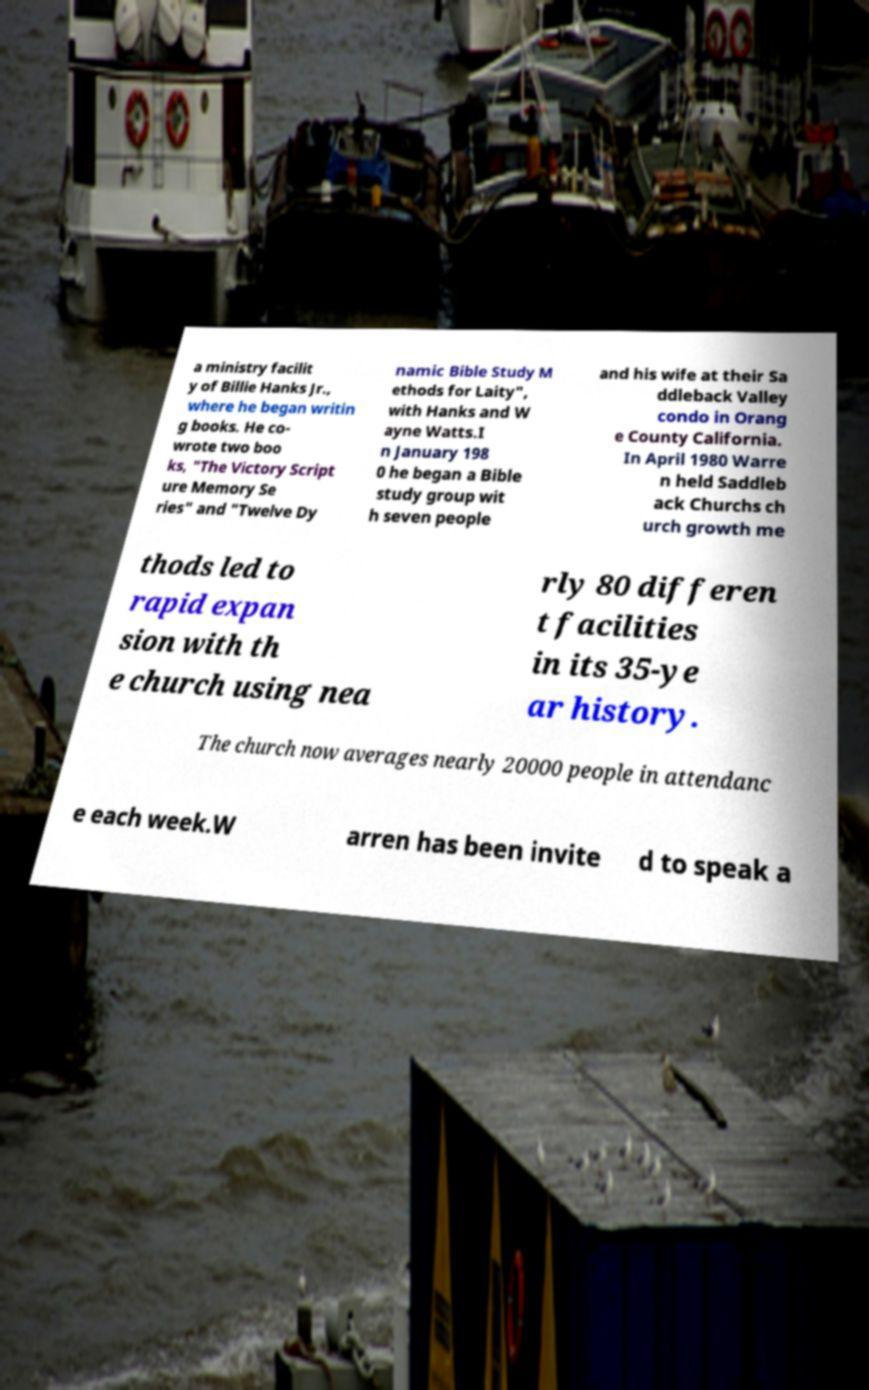For documentation purposes, I need the text within this image transcribed. Could you provide that? a ministry facilit y of Billie Hanks Jr., where he began writin g books. He co- wrote two boo ks, "The Victory Script ure Memory Se ries" and "Twelve Dy namic Bible Study M ethods for Laity", with Hanks and W ayne Watts.I n January 198 0 he began a Bible study group wit h seven people and his wife at their Sa ddleback Valley condo in Orang e County California. In April 1980 Warre n held Saddleb ack Churchs ch urch growth me thods led to rapid expan sion with th e church using nea rly 80 differen t facilities in its 35-ye ar history. The church now averages nearly 20000 people in attendanc e each week.W arren has been invite d to speak a 